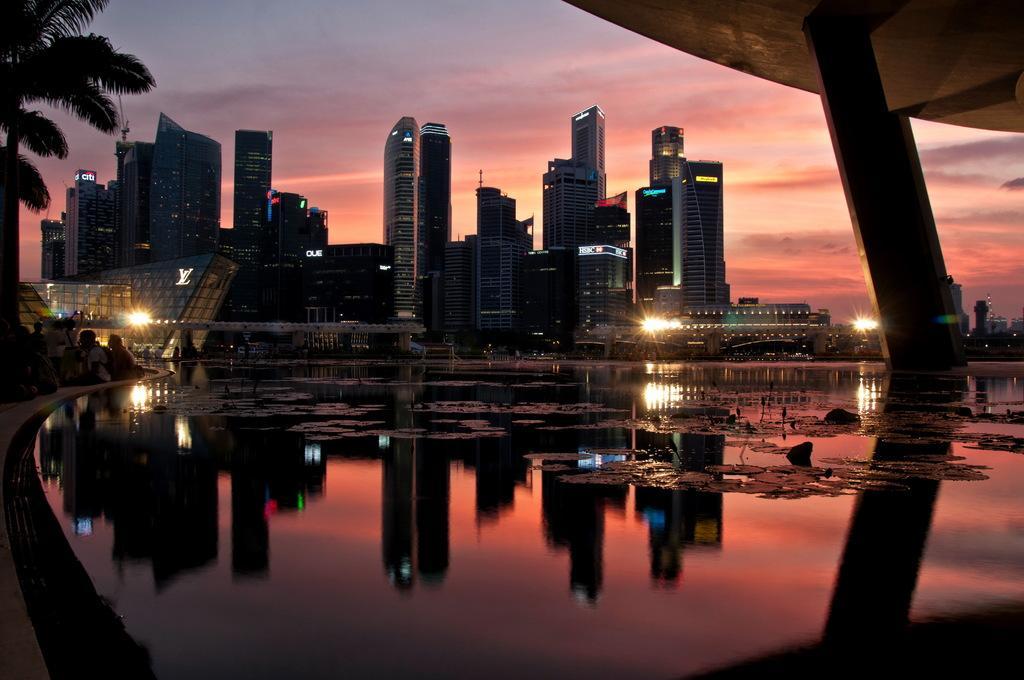Please provide a concise description of this image. In this image, we can see buildings, lights, some people and there is a bridge and we can see a tree. At the bottom, there is water and we can see some shadows. At the top, there is sky. 